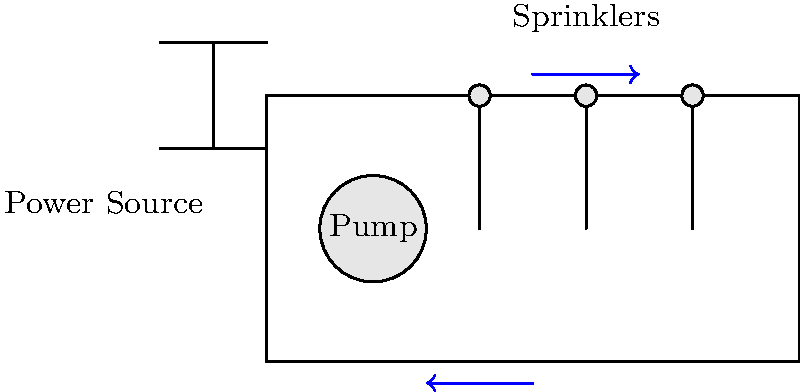In the farm irrigation system shown above, a pump is connected to three sprinklers. If the total current flowing through the system is $I = 15$ A and each sprinkler draws an equal amount of current, how much current flows through each individual sprinkler? To solve this problem, we'll follow these steps:

1. Understand the circuit: The pump and sprinklers are connected in parallel to the power source.

2. Recall Kirchhoff's Current Law: The total current entering a node equals the total current leaving the node.

3. Apply the concept to our system:
   - Total current ($I$) = Current through pump + Current through all sprinklers
   - $15 \text{ A} = I_{\text{pump}} + I_{\text{sprinklers}}$

4. Note that the current is divided equally among the three sprinklers:
   - $I_{\text{sprinklers}} = 3 \times I_{\text{each sprinkler}}$

5. Assume the pump uses a small amount of current, let's say 3 A:
   - $15 \text{ A} = 3 \text{ A} + 3 \times I_{\text{each sprinkler}}$

6. Solve for the current through each sprinkler:
   - $12 \text{ A} = 3 \times I_{\text{each sprinkler}}$
   - $I_{\text{each sprinkler}} = 12 \text{ A} \div 3 = 4 \text{ A}$

Therefore, each sprinkler draws 4 A of current.
Answer: 4 A 